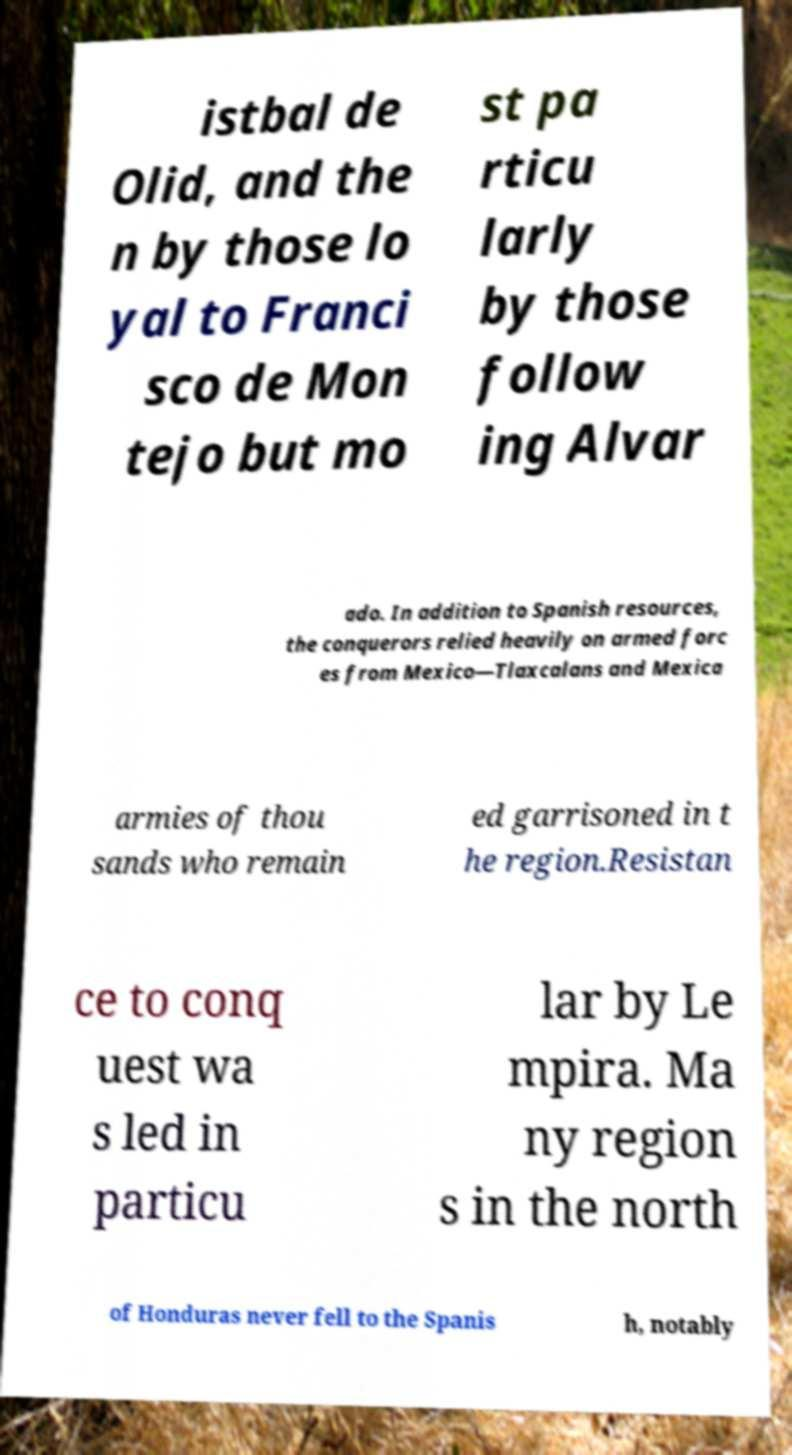Please read and relay the text visible in this image. What does it say? istbal de Olid, and the n by those lo yal to Franci sco de Mon tejo but mo st pa rticu larly by those follow ing Alvar ado. In addition to Spanish resources, the conquerors relied heavily on armed forc es from Mexico—Tlaxcalans and Mexica armies of thou sands who remain ed garrisoned in t he region.Resistan ce to conq uest wa s led in particu lar by Le mpira. Ma ny region s in the north of Honduras never fell to the Spanis h, notably 